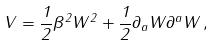<formula> <loc_0><loc_0><loc_500><loc_500>V = \frac { 1 } { 2 } \beta ^ { 2 } W ^ { 2 } + \frac { 1 } { 2 } \partial _ { a } W \partial ^ { a } W \, ,</formula> 